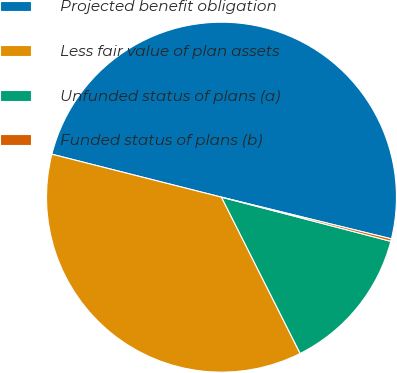Convert chart. <chart><loc_0><loc_0><loc_500><loc_500><pie_chart><fcel>Projected benefit obligation<fcel>Less fair value of plan assets<fcel>Unfunded status of plans (a)<fcel>Funded status of plans (b)<nl><fcel>49.88%<fcel>36.37%<fcel>13.52%<fcel>0.23%<nl></chart> 